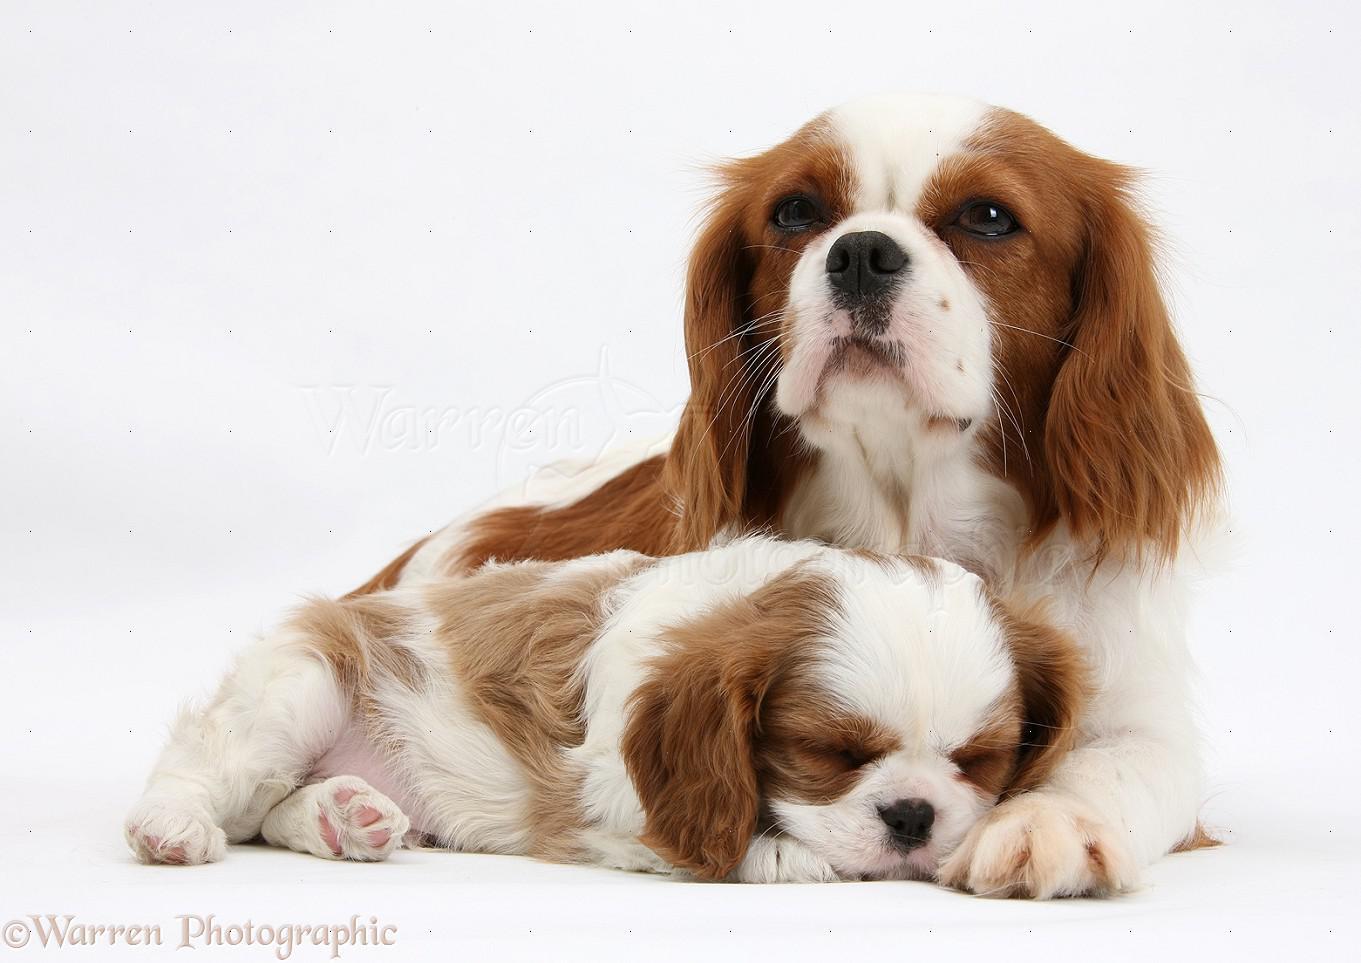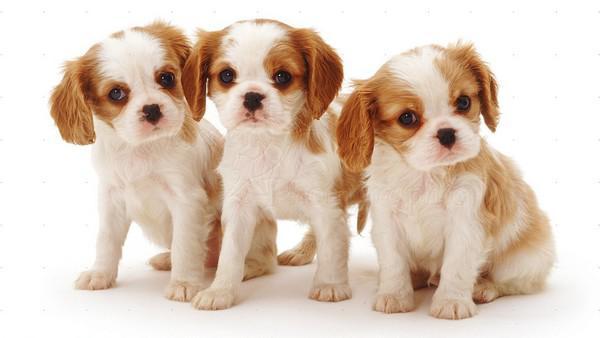The first image is the image on the left, the second image is the image on the right. Assess this claim about the two images: "One of the images contains exactly two puppies.". Correct or not? Answer yes or no. Yes. 